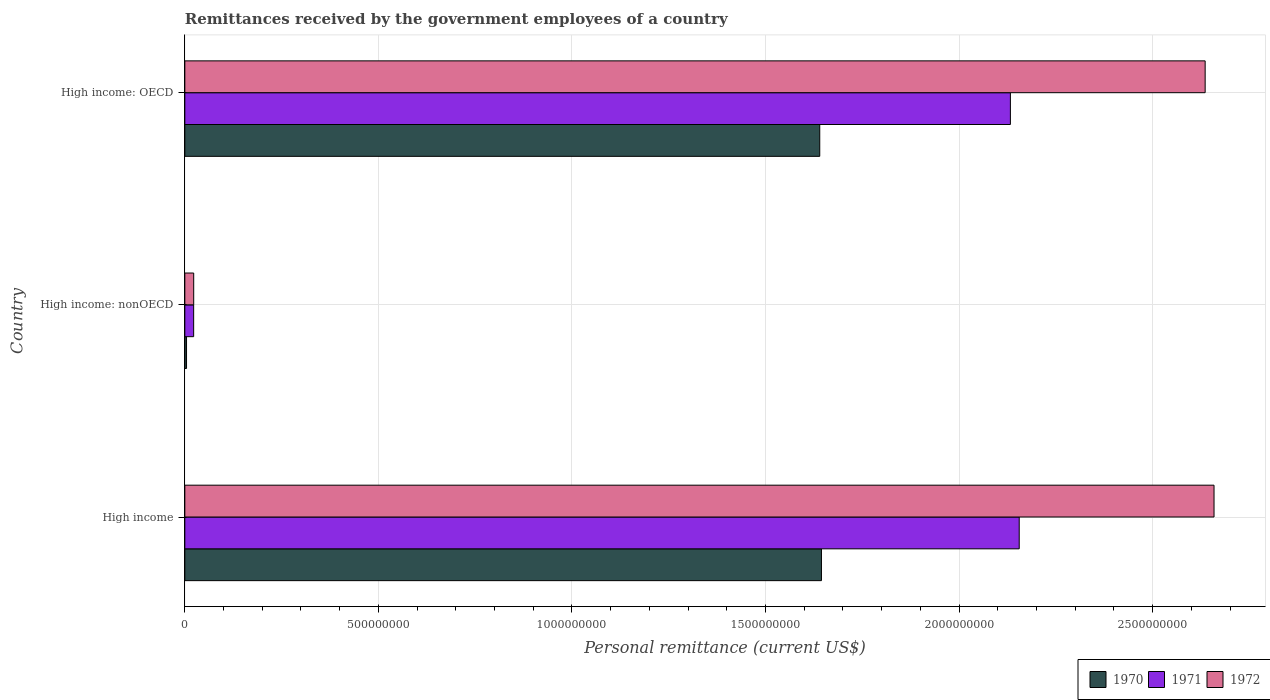How many groups of bars are there?
Provide a short and direct response. 3. Are the number of bars per tick equal to the number of legend labels?
Offer a terse response. Yes. How many bars are there on the 1st tick from the top?
Your answer should be compact. 3. What is the label of the 1st group of bars from the top?
Provide a short and direct response. High income: OECD. In how many cases, is the number of bars for a given country not equal to the number of legend labels?
Give a very brief answer. 0. What is the remittances received by the government employees in 1971 in High income: nonOECD?
Provide a succinct answer. 2.28e+07. Across all countries, what is the maximum remittances received by the government employees in 1972?
Provide a short and direct response. 2.66e+09. Across all countries, what is the minimum remittances received by the government employees in 1971?
Ensure brevity in your answer.  2.28e+07. In which country was the remittances received by the government employees in 1971 maximum?
Provide a short and direct response. High income. In which country was the remittances received by the government employees in 1970 minimum?
Your answer should be compact. High income: nonOECD. What is the total remittances received by the government employees in 1971 in the graph?
Provide a short and direct response. 4.31e+09. What is the difference between the remittances received by the government employees in 1971 in High income and that in High income: nonOECD?
Ensure brevity in your answer.  2.13e+09. What is the difference between the remittances received by the government employees in 1972 in High income and the remittances received by the government employees in 1970 in High income: nonOECD?
Ensure brevity in your answer.  2.65e+09. What is the average remittances received by the government employees in 1970 per country?
Provide a succinct answer. 1.10e+09. What is the difference between the remittances received by the government employees in 1972 and remittances received by the government employees in 1970 in High income: OECD?
Your answer should be compact. 9.96e+08. In how many countries, is the remittances received by the government employees in 1971 greater than 2100000000 US$?
Ensure brevity in your answer.  2. What is the ratio of the remittances received by the government employees in 1971 in High income to that in High income: OECD?
Offer a very short reply. 1.01. What is the difference between the highest and the second highest remittances received by the government employees in 1971?
Your response must be concise. 2.28e+07. What is the difference between the highest and the lowest remittances received by the government employees in 1972?
Offer a terse response. 2.64e+09. In how many countries, is the remittances received by the government employees in 1972 greater than the average remittances received by the government employees in 1972 taken over all countries?
Your answer should be compact. 2. Are the values on the major ticks of X-axis written in scientific E-notation?
Your response must be concise. No. Does the graph contain grids?
Offer a terse response. Yes. Where does the legend appear in the graph?
Provide a succinct answer. Bottom right. What is the title of the graph?
Give a very brief answer. Remittances received by the government employees of a country. What is the label or title of the X-axis?
Make the answer very short. Personal remittance (current US$). What is the label or title of the Y-axis?
Your answer should be compact. Country. What is the Personal remittance (current US$) of 1970 in High income?
Your response must be concise. 1.64e+09. What is the Personal remittance (current US$) in 1971 in High income?
Give a very brief answer. 2.16e+09. What is the Personal remittance (current US$) of 1972 in High income?
Give a very brief answer. 2.66e+09. What is the Personal remittance (current US$) in 1970 in High income: nonOECD?
Provide a short and direct response. 4.40e+06. What is the Personal remittance (current US$) in 1971 in High income: nonOECD?
Your answer should be very brief. 2.28e+07. What is the Personal remittance (current US$) of 1972 in High income: nonOECD?
Keep it short and to the point. 2.29e+07. What is the Personal remittance (current US$) in 1970 in High income: OECD?
Offer a terse response. 1.64e+09. What is the Personal remittance (current US$) in 1971 in High income: OECD?
Keep it short and to the point. 2.13e+09. What is the Personal remittance (current US$) in 1972 in High income: OECD?
Offer a terse response. 2.64e+09. Across all countries, what is the maximum Personal remittance (current US$) of 1970?
Make the answer very short. 1.64e+09. Across all countries, what is the maximum Personal remittance (current US$) of 1971?
Your answer should be very brief. 2.16e+09. Across all countries, what is the maximum Personal remittance (current US$) of 1972?
Give a very brief answer. 2.66e+09. Across all countries, what is the minimum Personal remittance (current US$) of 1970?
Provide a succinct answer. 4.40e+06. Across all countries, what is the minimum Personal remittance (current US$) of 1971?
Your answer should be very brief. 2.28e+07. Across all countries, what is the minimum Personal remittance (current US$) of 1972?
Provide a succinct answer. 2.29e+07. What is the total Personal remittance (current US$) in 1970 in the graph?
Provide a short and direct response. 3.29e+09. What is the total Personal remittance (current US$) of 1971 in the graph?
Offer a terse response. 4.31e+09. What is the total Personal remittance (current US$) of 1972 in the graph?
Keep it short and to the point. 5.32e+09. What is the difference between the Personal remittance (current US$) of 1970 in High income and that in High income: nonOECD?
Provide a succinct answer. 1.64e+09. What is the difference between the Personal remittance (current US$) in 1971 in High income and that in High income: nonOECD?
Offer a terse response. 2.13e+09. What is the difference between the Personal remittance (current US$) in 1972 in High income and that in High income: nonOECD?
Your response must be concise. 2.64e+09. What is the difference between the Personal remittance (current US$) in 1970 in High income and that in High income: OECD?
Give a very brief answer. 4.40e+06. What is the difference between the Personal remittance (current US$) in 1971 in High income and that in High income: OECD?
Offer a very short reply. 2.28e+07. What is the difference between the Personal remittance (current US$) in 1972 in High income and that in High income: OECD?
Keep it short and to the point. 2.29e+07. What is the difference between the Personal remittance (current US$) in 1970 in High income: nonOECD and that in High income: OECD?
Make the answer very short. -1.64e+09. What is the difference between the Personal remittance (current US$) in 1971 in High income: nonOECD and that in High income: OECD?
Keep it short and to the point. -2.11e+09. What is the difference between the Personal remittance (current US$) of 1972 in High income: nonOECD and that in High income: OECD?
Ensure brevity in your answer.  -2.61e+09. What is the difference between the Personal remittance (current US$) of 1970 in High income and the Personal remittance (current US$) of 1971 in High income: nonOECD?
Your answer should be compact. 1.62e+09. What is the difference between the Personal remittance (current US$) of 1970 in High income and the Personal remittance (current US$) of 1972 in High income: nonOECD?
Your response must be concise. 1.62e+09. What is the difference between the Personal remittance (current US$) in 1971 in High income and the Personal remittance (current US$) in 1972 in High income: nonOECD?
Your answer should be compact. 2.13e+09. What is the difference between the Personal remittance (current US$) of 1970 in High income and the Personal remittance (current US$) of 1971 in High income: OECD?
Your answer should be compact. -4.88e+08. What is the difference between the Personal remittance (current US$) in 1970 in High income and the Personal remittance (current US$) in 1972 in High income: OECD?
Keep it short and to the point. -9.91e+08. What is the difference between the Personal remittance (current US$) in 1971 in High income and the Personal remittance (current US$) in 1972 in High income: OECD?
Provide a short and direct response. -4.80e+08. What is the difference between the Personal remittance (current US$) of 1970 in High income: nonOECD and the Personal remittance (current US$) of 1971 in High income: OECD?
Give a very brief answer. -2.13e+09. What is the difference between the Personal remittance (current US$) of 1970 in High income: nonOECD and the Personal remittance (current US$) of 1972 in High income: OECD?
Your answer should be compact. -2.63e+09. What is the difference between the Personal remittance (current US$) of 1971 in High income: nonOECD and the Personal remittance (current US$) of 1972 in High income: OECD?
Give a very brief answer. -2.61e+09. What is the average Personal remittance (current US$) in 1970 per country?
Provide a short and direct response. 1.10e+09. What is the average Personal remittance (current US$) of 1971 per country?
Provide a short and direct response. 1.44e+09. What is the average Personal remittance (current US$) in 1972 per country?
Ensure brevity in your answer.  1.77e+09. What is the difference between the Personal remittance (current US$) in 1970 and Personal remittance (current US$) in 1971 in High income?
Your answer should be compact. -5.11e+08. What is the difference between the Personal remittance (current US$) in 1970 and Personal remittance (current US$) in 1972 in High income?
Your response must be concise. -1.01e+09. What is the difference between the Personal remittance (current US$) in 1971 and Personal remittance (current US$) in 1972 in High income?
Keep it short and to the point. -5.03e+08. What is the difference between the Personal remittance (current US$) in 1970 and Personal remittance (current US$) in 1971 in High income: nonOECD?
Provide a short and direct response. -1.84e+07. What is the difference between the Personal remittance (current US$) in 1970 and Personal remittance (current US$) in 1972 in High income: nonOECD?
Your response must be concise. -1.85e+07. What is the difference between the Personal remittance (current US$) in 1971 and Personal remittance (current US$) in 1972 in High income: nonOECD?
Your response must be concise. -1.37e+05. What is the difference between the Personal remittance (current US$) of 1970 and Personal remittance (current US$) of 1971 in High income: OECD?
Ensure brevity in your answer.  -4.92e+08. What is the difference between the Personal remittance (current US$) in 1970 and Personal remittance (current US$) in 1972 in High income: OECD?
Give a very brief answer. -9.96e+08. What is the difference between the Personal remittance (current US$) in 1971 and Personal remittance (current US$) in 1972 in High income: OECD?
Ensure brevity in your answer.  -5.03e+08. What is the ratio of the Personal remittance (current US$) in 1970 in High income to that in High income: nonOECD?
Provide a short and direct response. 373.75. What is the ratio of the Personal remittance (current US$) in 1971 in High income to that in High income: nonOECD?
Provide a short and direct response. 94.6. What is the ratio of the Personal remittance (current US$) of 1972 in High income to that in High income: nonOECD?
Offer a very short reply. 115.99. What is the ratio of the Personal remittance (current US$) in 1971 in High income to that in High income: OECD?
Give a very brief answer. 1.01. What is the ratio of the Personal remittance (current US$) of 1972 in High income to that in High income: OECD?
Make the answer very short. 1.01. What is the ratio of the Personal remittance (current US$) in 1970 in High income: nonOECD to that in High income: OECD?
Keep it short and to the point. 0. What is the ratio of the Personal remittance (current US$) of 1971 in High income: nonOECD to that in High income: OECD?
Offer a terse response. 0.01. What is the ratio of the Personal remittance (current US$) in 1972 in High income: nonOECD to that in High income: OECD?
Your response must be concise. 0.01. What is the difference between the highest and the second highest Personal remittance (current US$) of 1970?
Ensure brevity in your answer.  4.40e+06. What is the difference between the highest and the second highest Personal remittance (current US$) of 1971?
Give a very brief answer. 2.28e+07. What is the difference between the highest and the second highest Personal remittance (current US$) in 1972?
Your answer should be very brief. 2.29e+07. What is the difference between the highest and the lowest Personal remittance (current US$) of 1970?
Provide a succinct answer. 1.64e+09. What is the difference between the highest and the lowest Personal remittance (current US$) of 1971?
Make the answer very short. 2.13e+09. What is the difference between the highest and the lowest Personal remittance (current US$) of 1972?
Make the answer very short. 2.64e+09. 